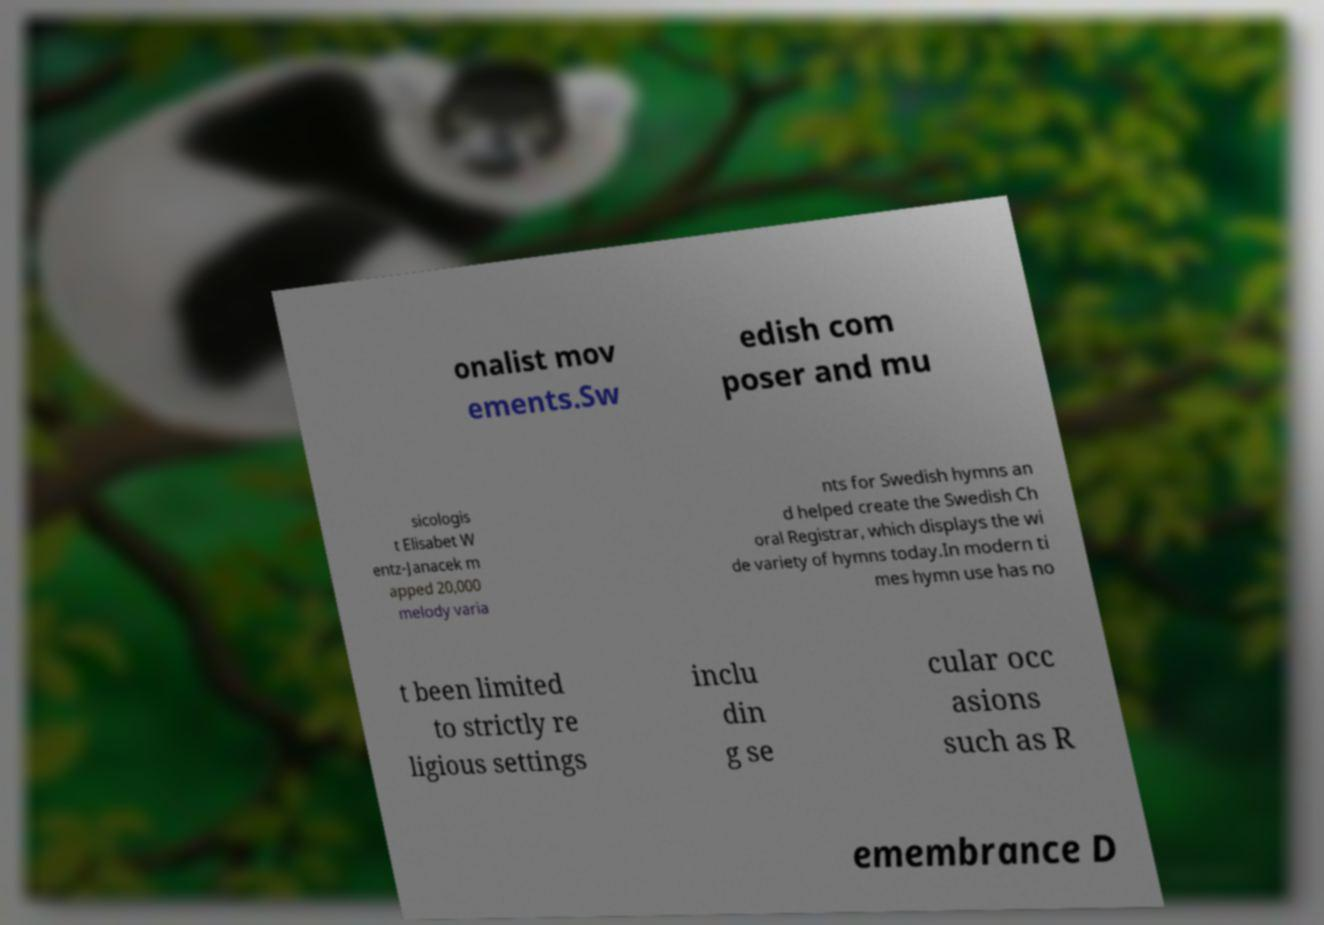There's text embedded in this image that I need extracted. Can you transcribe it verbatim? onalist mov ements.Sw edish com poser and mu sicologis t Elisabet W entz-Janacek m apped 20,000 melody varia nts for Swedish hymns an d helped create the Swedish Ch oral Registrar, which displays the wi de variety of hymns today.In modern ti mes hymn use has no t been limited to strictly re ligious settings inclu din g se cular occ asions such as R emembrance D 